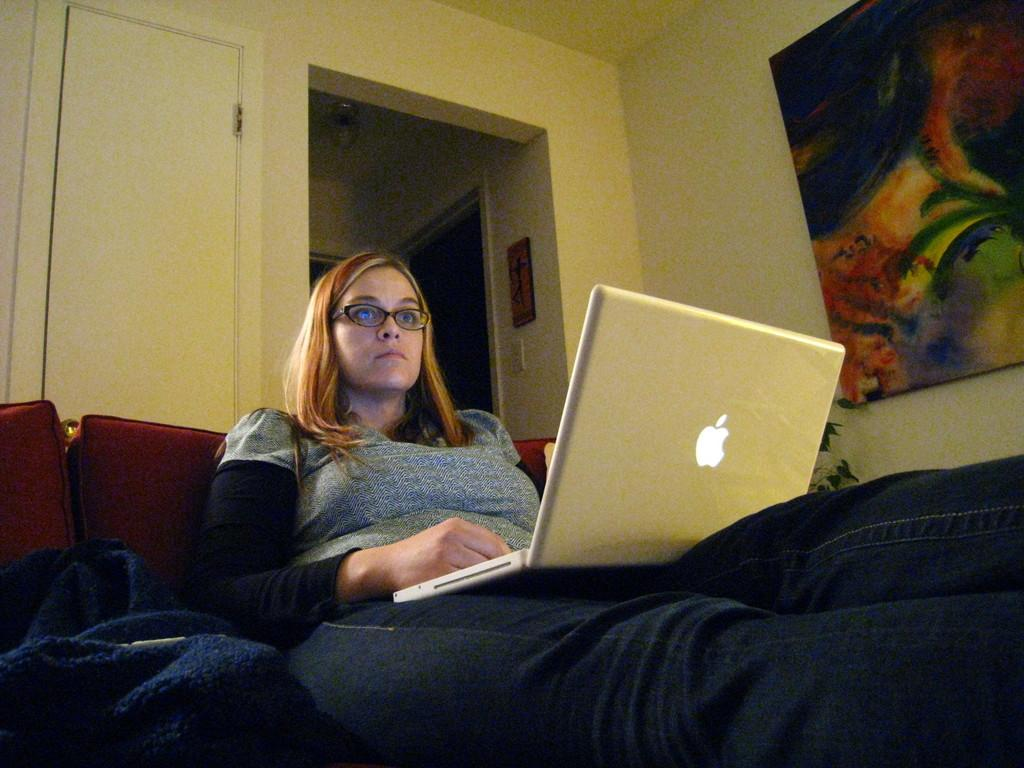Who is present in the image? There is a woman in the image. What is the woman doing in the image? The woman is sitting on a couch. What object is the woman holding or using in the image? The woman has a laptop on her thighs. What can be seen in the background of the image? There is a plant and frames attached to the wall in the background of the image. Can you see a river flowing behind the woman in the image? No, there is no river visible in the image. 